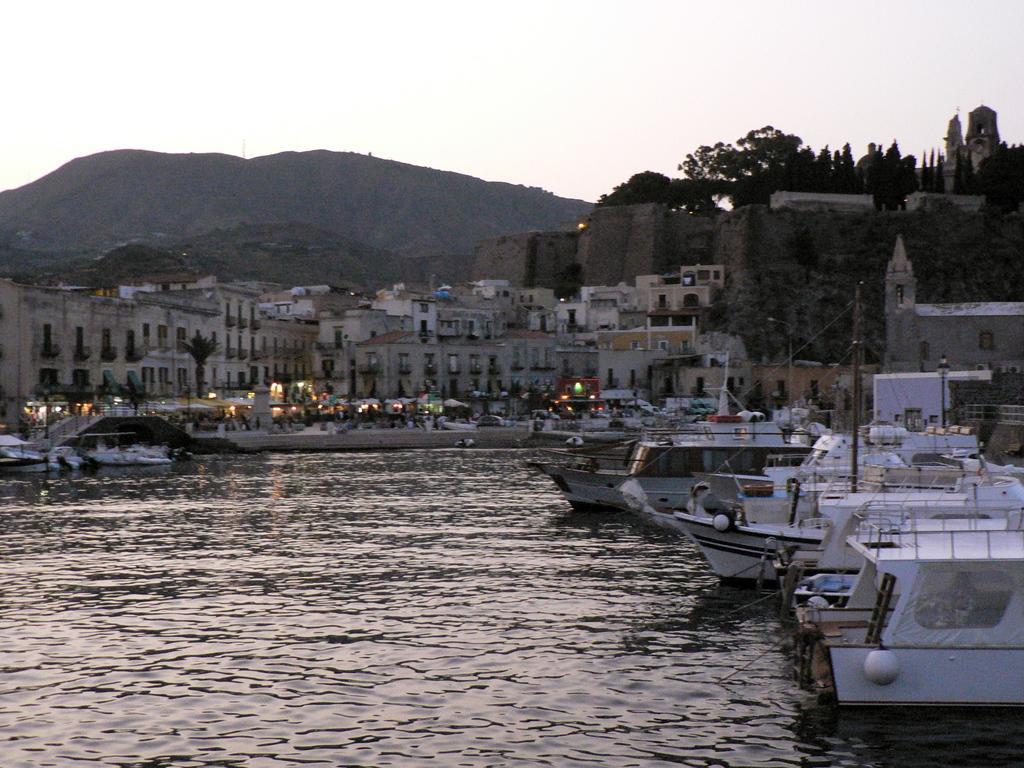Can you describe this image briefly? In this picture we can see some ships are in the water, around we can see buildings, trees, hills. 